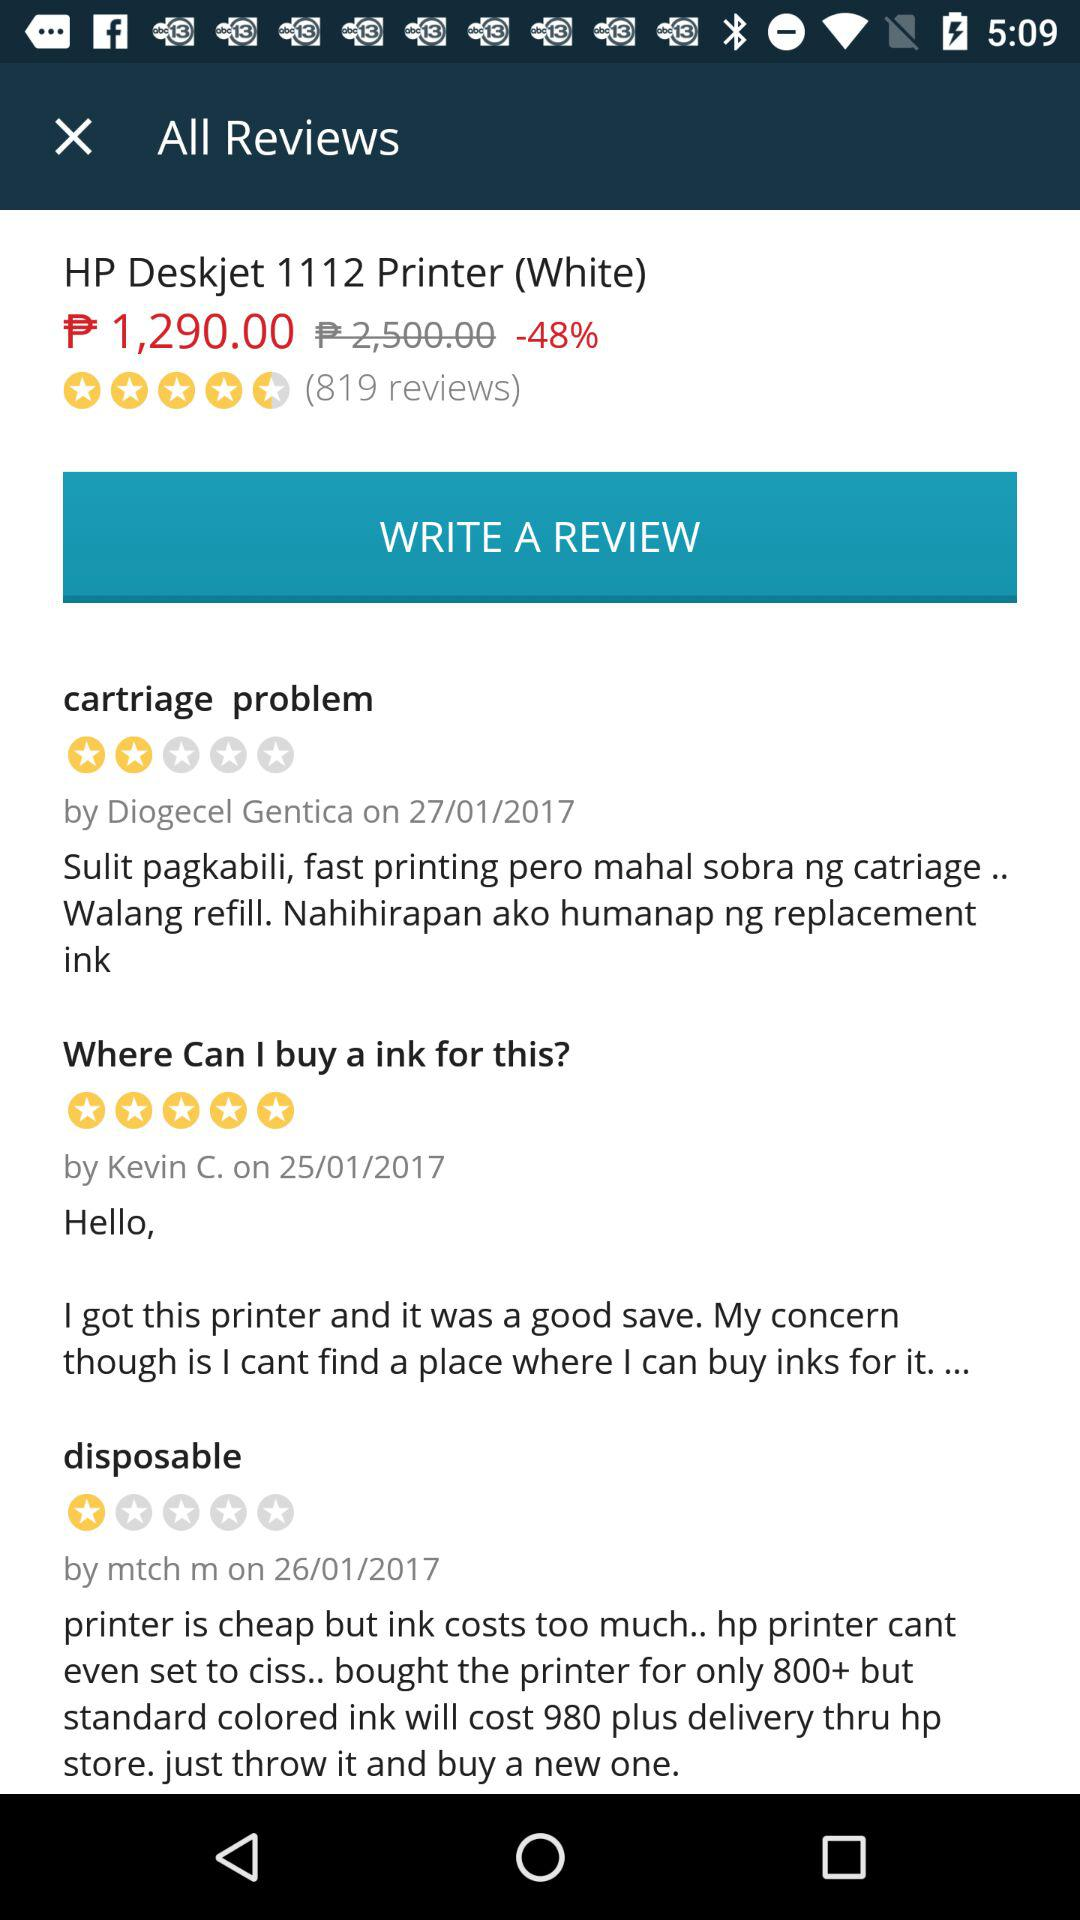How many reviews in total are there? There are total 819 reviews. 